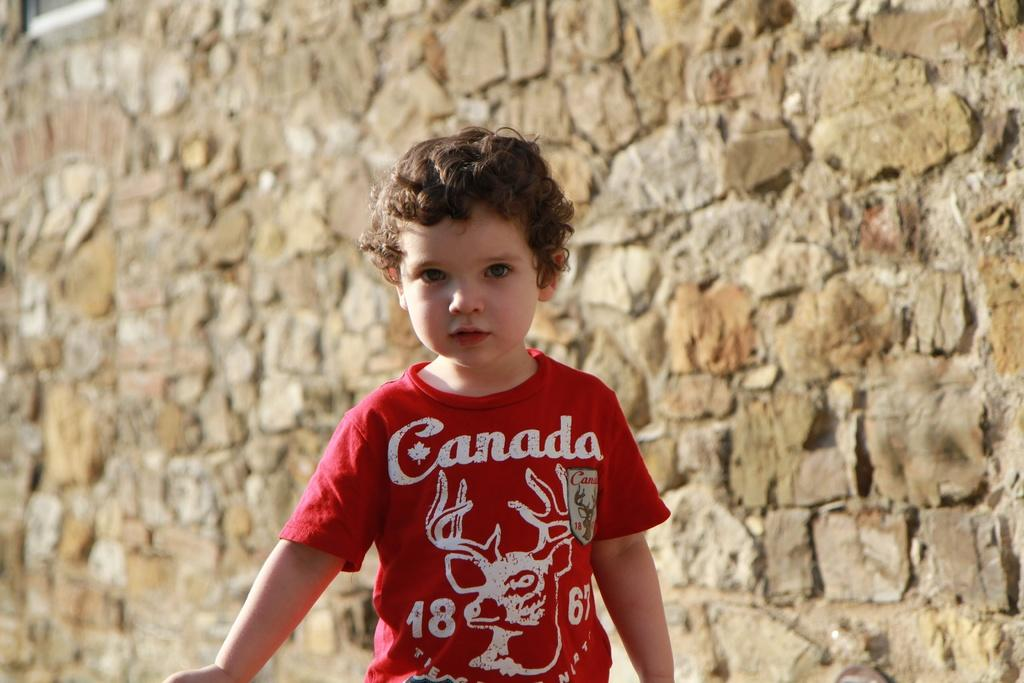What is the main subject in the foreground of the image? There is a small boy in the foreground of the image. What can be seen in the background of the image? There is a wall in the background of the image. What type of feast is the small boy attending in the image? There is no indication of a feast or any gathering in the image; it simply features a small boy in the foreground and a wall in the background. 